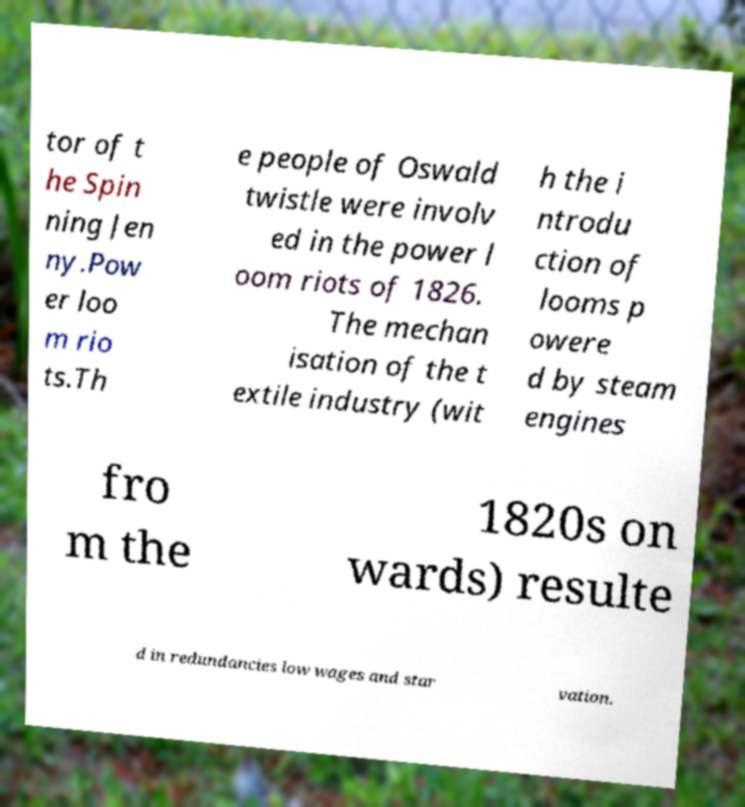Can you read and provide the text displayed in the image?This photo seems to have some interesting text. Can you extract and type it out for me? tor of t he Spin ning Jen ny.Pow er loo m rio ts.Th e people of Oswald twistle were involv ed in the power l oom riots of 1826. The mechan isation of the t extile industry (wit h the i ntrodu ction of looms p owere d by steam engines fro m the 1820s on wards) resulte d in redundancies low wages and star vation. 